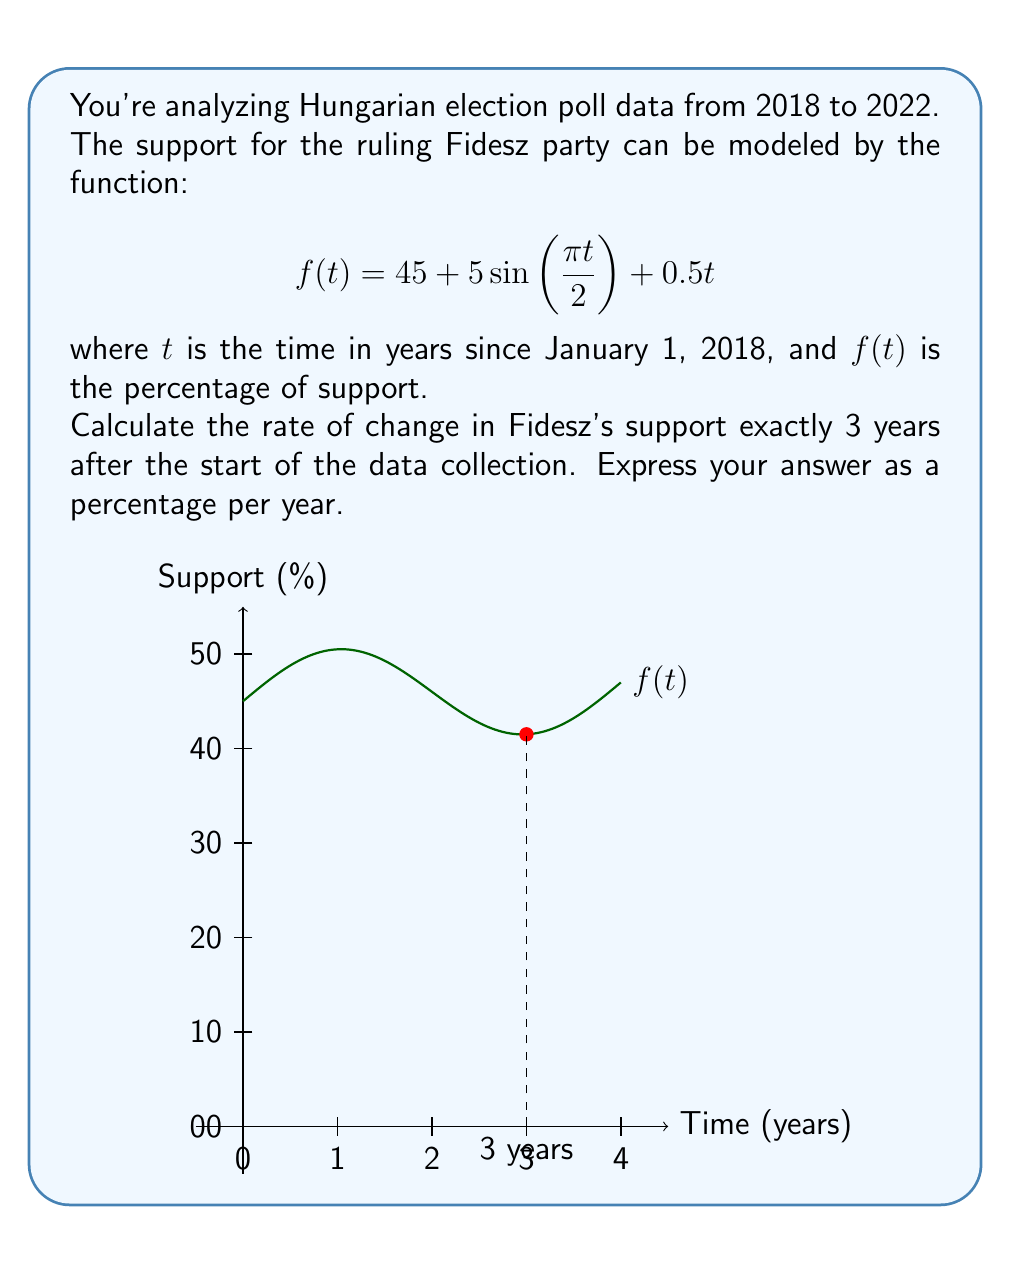Solve this math problem. To solve this problem, we need to find the derivative of the function $f(t)$ and evaluate it at $t=3$. Let's break it down step-by-step:

1) The given function is:
   $$f(t) = 45 + 5\sin(\frac{\pi t}{2}) + 0.5t$$

2) To find the rate of change, we need to differentiate $f(t)$ with respect to $t$:
   $$f'(t) = 5 \cdot \frac{\pi}{2} \cos(\frac{\pi t}{2}) + 0.5$$

3) Now, we need to evaluate $f'(3)$:
   $$f'(3) = 5 \cdot \frac{\pi}{2} \cos(\frac{3\pi}{2}) + 0.5$$

4) Simplify:
   $$f'(3) = \frac{5\pi}{2} \cdot 0 + 0.5 = 0.5$$

5) The result, 0.5, represents the rate of change in percentage points per year.

Therefore, exactly 3 years after the start of data collection, Fidesz's support was increasing at a rate of 0.5 percentage points per year.
Answer: 0.5% per year 